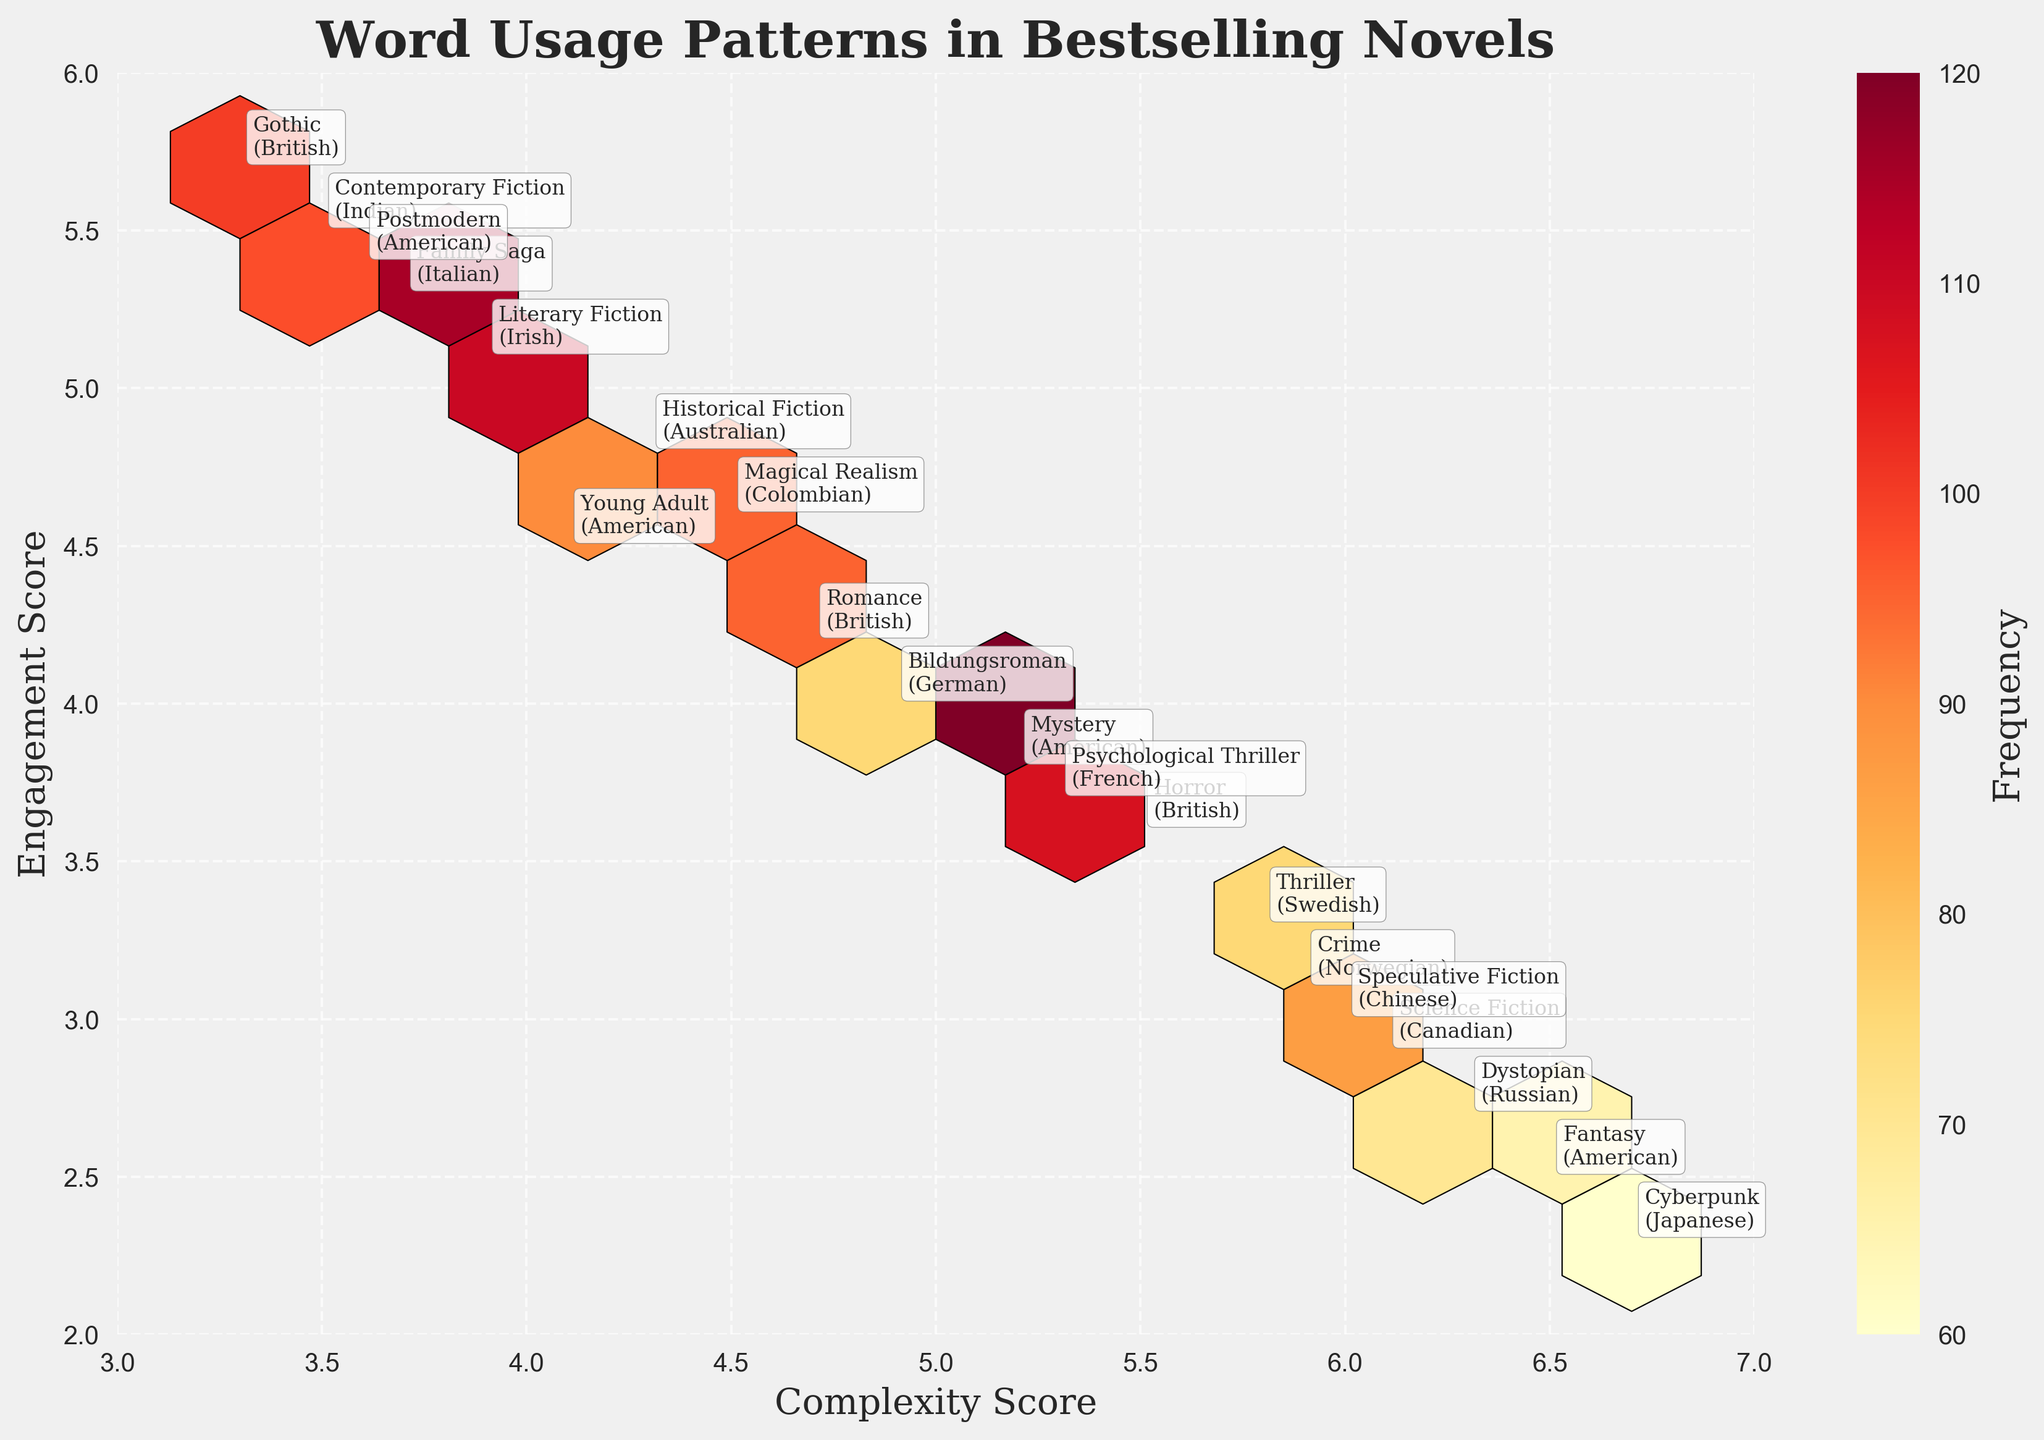What is the title of the hexbin plot? The title of the hexbin plot is displayed at the top center of the figure. It reads "Word Usage Patterns in Bestselling Novels".
Answer: Word Usage Patterns in Bestselling Novels How many genres are represented in the plot? Each genre is annotated on the plot beside each hexbin. Counting these annotations gives the total number of genres.
Answer: 20 What are the axes labels of the hexbin plot? The labels of the axes are displayed along the horizontal and vertical axes of the plot. The x-axis is labeled "Complexity Score" and the y-axis is labeled "Engagement Score".
Answer: Complexity Score and Engagement Score Which genre has the highest frequency count? By looking at the color intensity in the hexbin plot (where higher frequencies are shown in darker colors) and checking the annotations, the hexbin with the highest frequency must be identified. The Mystery genre with a score of (5.2, 3.8) has the highest frequency (120).
Answer: Mystery What genre and nationality are represented by the hexbin located at (4.7, 4.2)? This particular hexbin at (4.7, 4.2) is annotated directly in the plot. The annotation shows the genre as Romance and the nationality as British.
Answer: Romance, British How many genres have an engagement score greater than 4.5? Engaging scores greater than 4.5 are indicated by y-values above 4.5. By identifying and counting each of these, one can determine the number. The genres are Literary Fiction, Historical Fiction, Contemporary Fiction, Family Saga, Gothic, and Postmodern.
Answer: 6 Which genre has the lowest complexity score? The complexity score is represented on the x-axis. The genre with the lowest x-value (3.3) is Gothic.
Answer: Gothic Compare the frequencies of the genres with the highest engagement score and the lowest complexity score. Identify the frequencies for both - Family Saga has the highest engagement score (5.5) with a frequency of 115, while Gothic has the lowest complexity score (3.3) with a frequency of 100.
Answer: Family Saga: 115, Gothic: 100 What are the average complexity and engagement scores for British authors? Locate British authors on the plot (Romance: (4.7, 4.2), Horror: (5.5, 3.6), and Gothic: (3.3, 5.7)), sum their scores and divide by the number of authors. Complexity: (4.7 + 5.5 + 3.3)/3 = 4.5, Engagement: (4.2 + 3.6 + 5.7)/3 ≈ 4.5.
Answer: 4.5, 4.5 Which genre has the most distinct nationality compared to others in the plot? By looking at the annotations, Cyberpunk is the only genre represented by Japanese nationality making it the most distinct.
Answer: Cyberpunk 